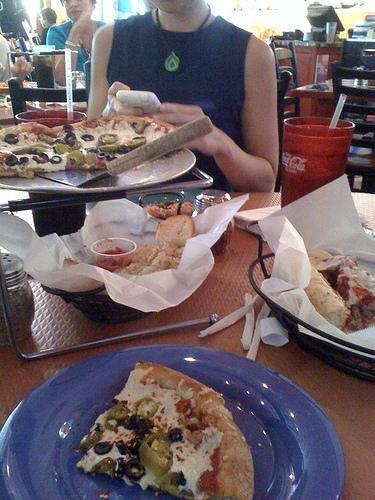How many blue plates are there?
Give a very brief answer. 1. 